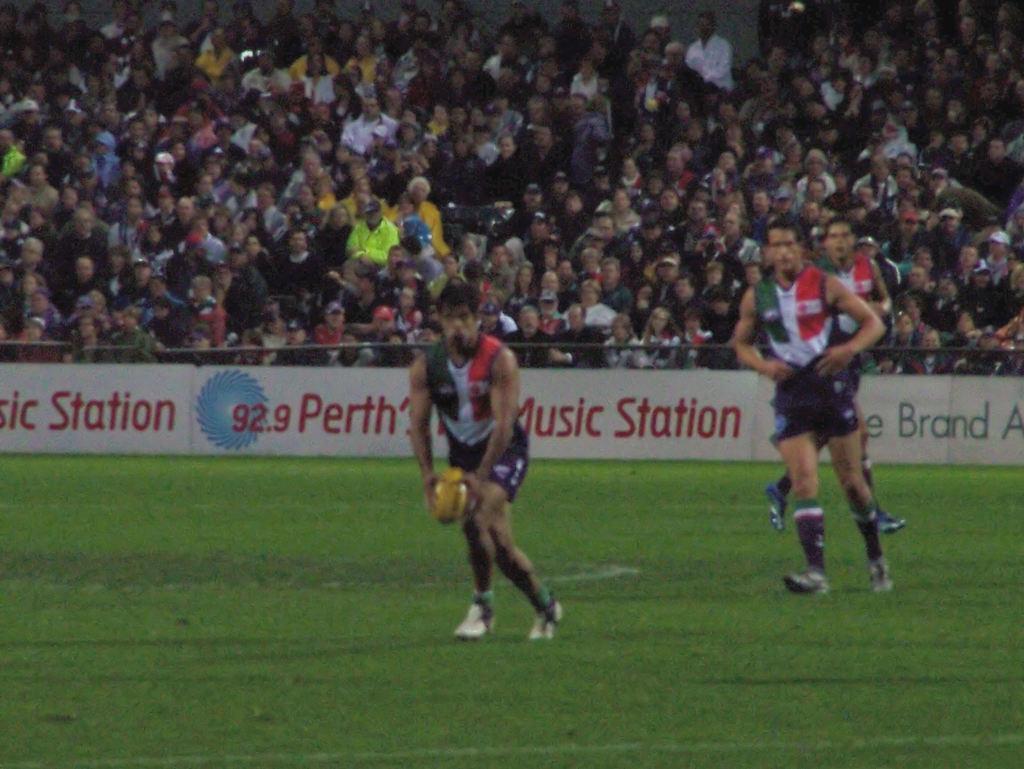Describe this image in one or two sentences. In this image I can see a man holding a rugby ball on his hands and running. Behind I can see two more men running. At background I can see group of people sitting and watching the rugby game. This is a banner which is kept along the way as a compound wall. 